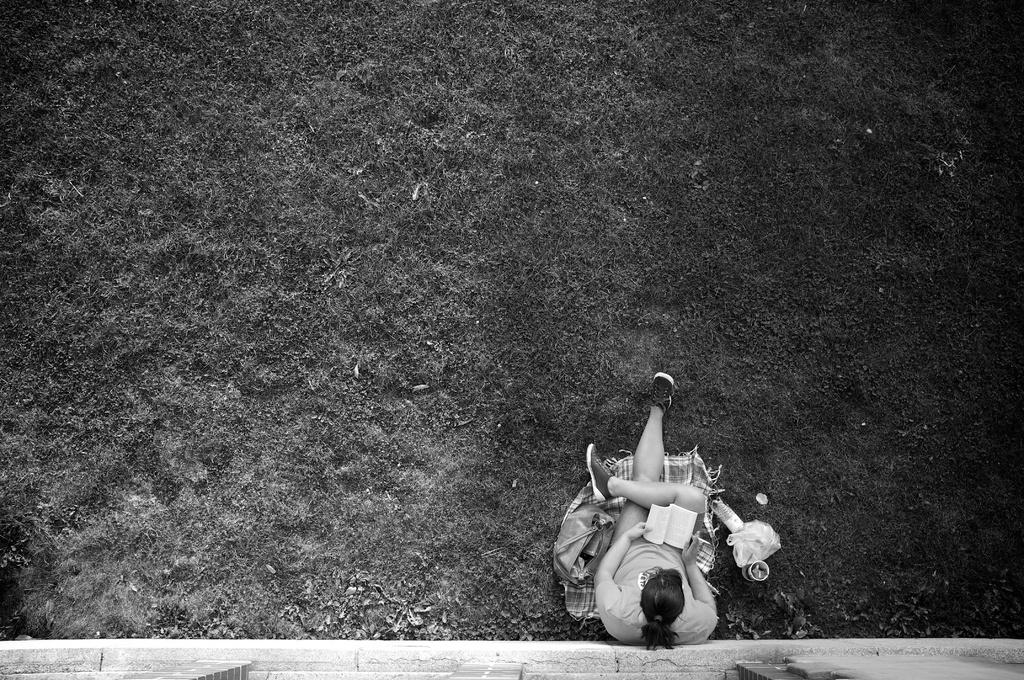What is the person in the image doing? The person is sitting and reading a book in the image. What objects can be seen on the ground in the image? There is a bag, a cup, a cloth, a cover, a bottle, and other unspecified things on the ground in the image. What type of surface is visible on the ground? Grass is visible on the ground in the image. Can you see any planes flying in the image? There is no mention of a plane in the image, so it cannot be confirmed if any are visible. Are there any fairies visible in the image? There is no mention of fairies in the image, so it cannot be confirmed if any are visible. 